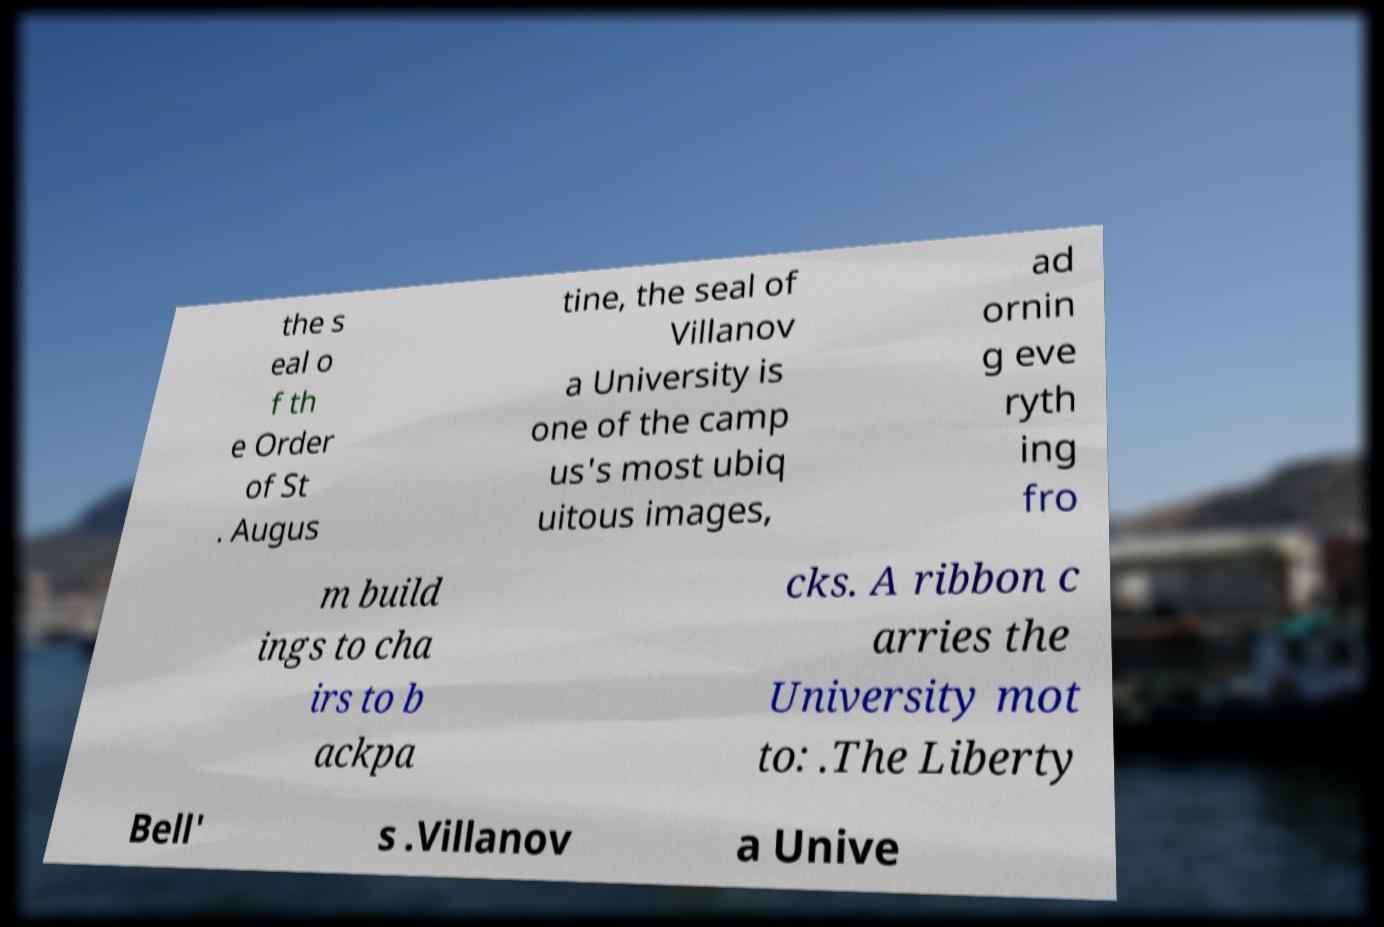There's text embedded in this image that I need extracted. Can you transcribe it verbatim? the s eal o f th e Order of St . Augus tine, the seal of Villanov a University is one of the camp us's most ubiq uitous images, ad ornin g eve ryth ing fro m build ings to cha irs to b ackpa cks. A ribbon c arries the University mot to: .The Liberty Bell' s .Villanov a Unive 